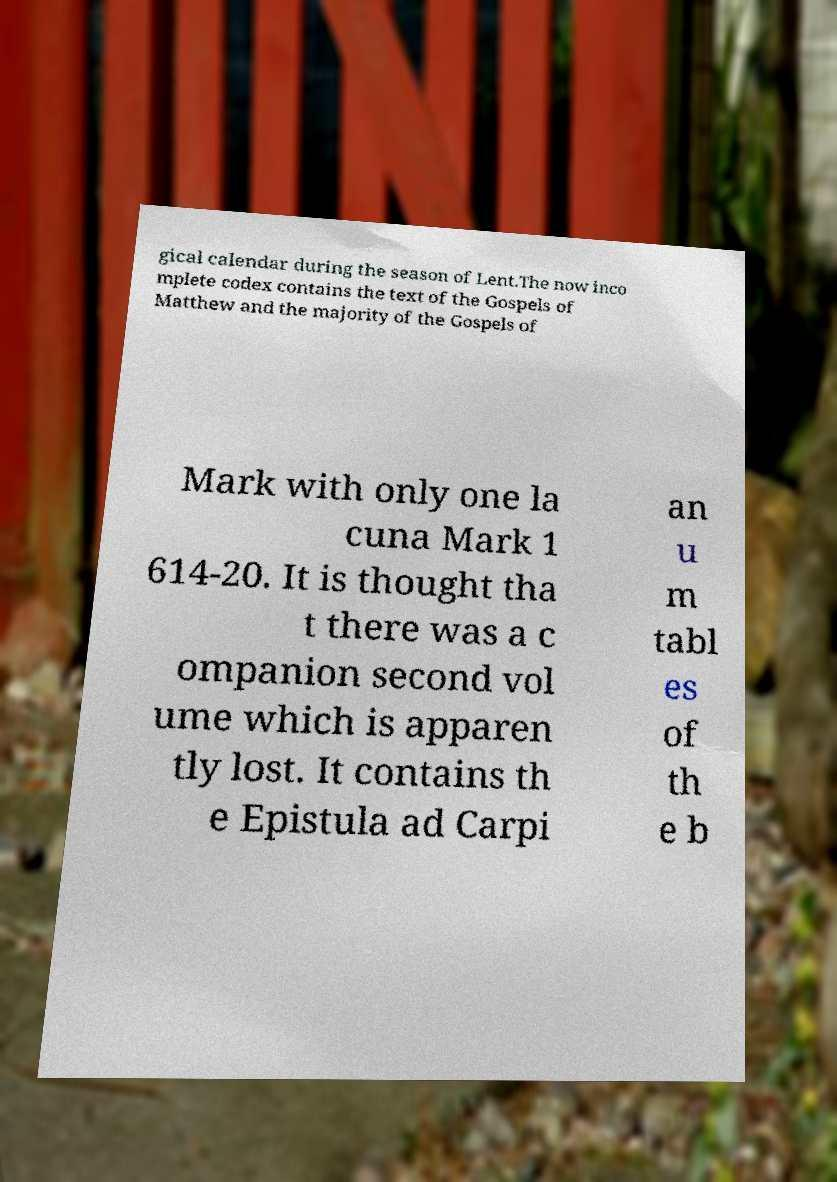What messages or text are displayed in this image? I need them in a readable, typed format. gical calendar during the season of Lent.The now inco mplete codex contains the text of the Gospels of Matthew and the majority of the Gospels of Mark with only one la cuna Mark 1 614-20. It is thought tha t there was a c ompanion second vol ume which is apparen tly lost. It contains th e Epistula ad Carpi an u m tabl es of th e b 